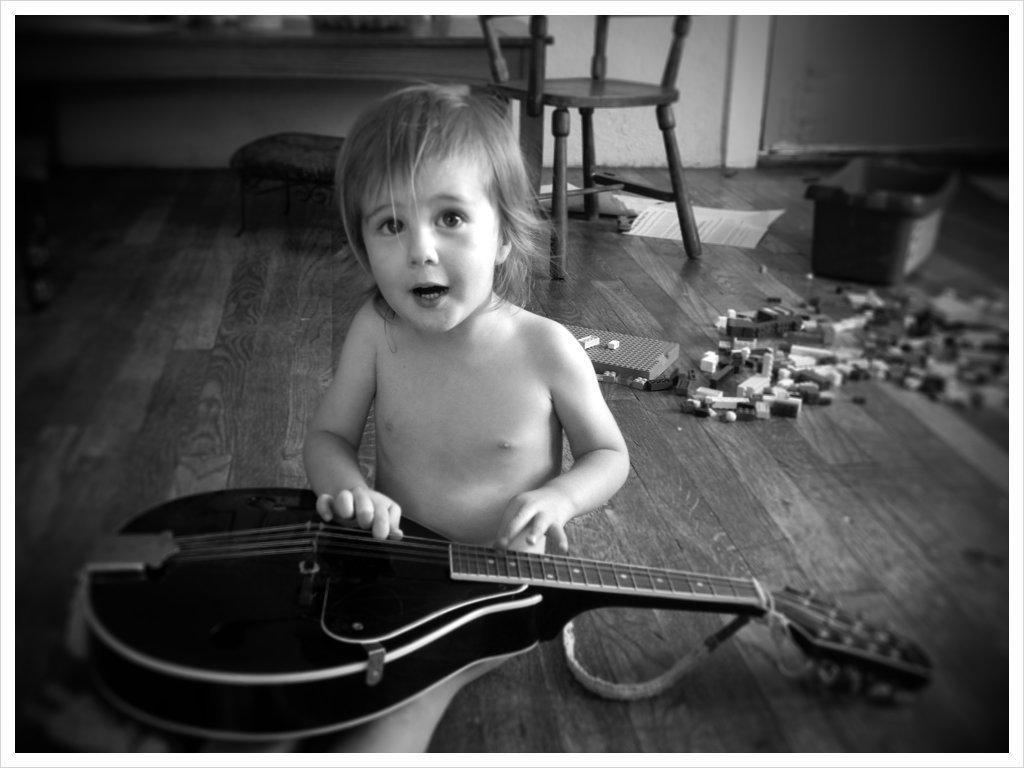Can you describe this image briefly? Child sitting on the ground,playing guitar and in background there is chair and there is a table and ground there are toys. 